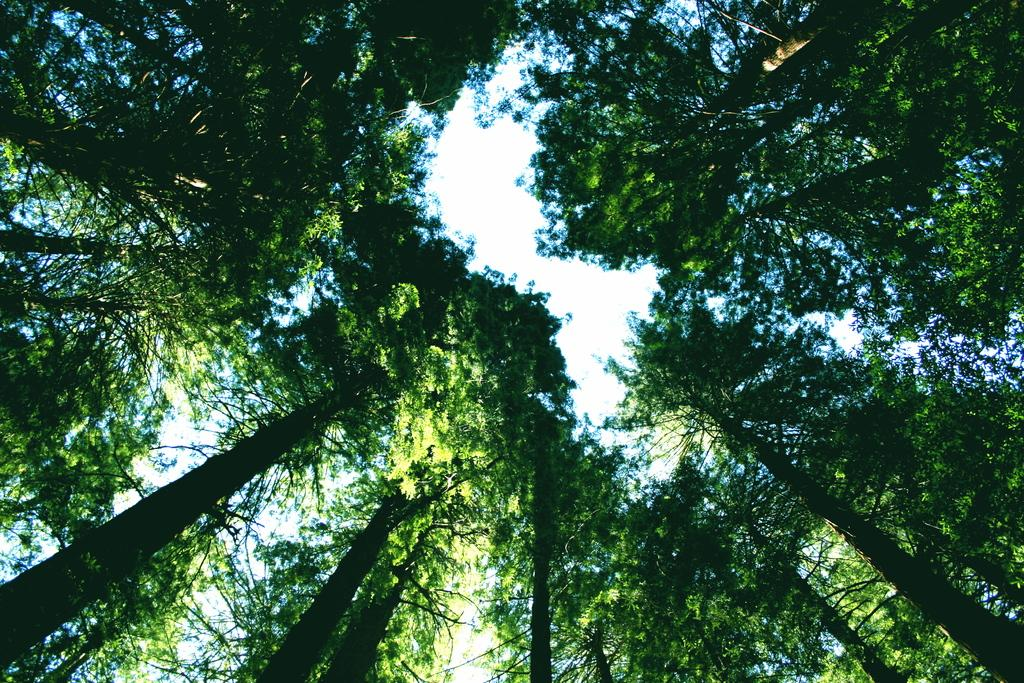What type of vegetation can be seen in the image? There are trees in the image. What part of the natural environment is visible in the image? The sky is visible in the image. How many corks are hanging from the trees in the image? There are no corks present in the image; it features trees and the sky. What type of wish can be granted by looking at the image? There is no specific wish that can be granted by looking at the image, as it only contains trees and the sky. 